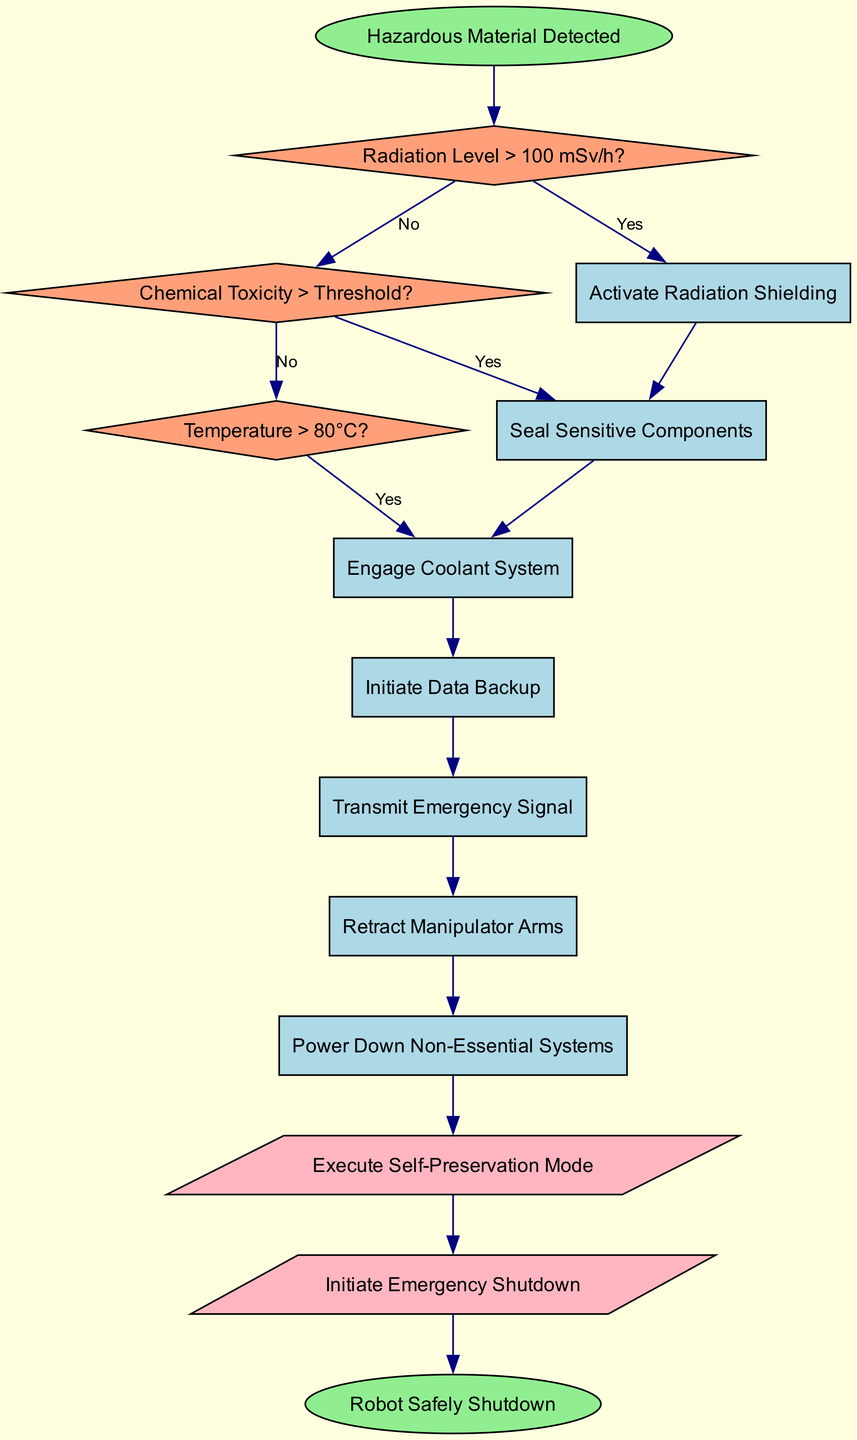What is the starting point of the flowchart? The flowchart begins with the node labeled "Hazardous Material Detected," which is defined as the starting point in the data provided.
Answer: Hazardous Material Detected How many decision nodes are in the diagram? By counting the items in the "decisions" array from the data, there are three decision nodes represented in the flowchart.
Answer: 3 What action follows after detecting a radiation level greater than 100 mSv/h? If the condition of "Radiation Level > 100 mSv/h?" is met (i.e., answered 'Yes'), the corresponding action is to "Activate Radiation Shielding" as indicated in the flowchart.
Answer: Activate Radiation Shielding What is the last action performed before the end node? The last action pointing to the final actions is "Power Down Non-Essential Systems," which leads to the final actions of self-preservation and emergency shutdown.
Answer: Power Down Non-Essential Systems If chemical toxicity exceeds the threshold, which action is taken after that? Upon identifying the condition "Chemical Toxicity > Threshold?" as true (Yes), the immediate corresponding action is to "Seal Sensitive Components."
Answer: Seal Sensitive Components What is the significance of the final actions in the flowchart? The final actions serve specific purposes for the robot, which are to execute a self-preservation mode and then to initiate an emergency shutdown process, thus ensuring the safety of the robot during hazardous conditions.
Answer: Execute Self-Preservation Mode and Initiate Emergency Shutdown Which action might be executed if the temperature exceeds 80°C? If the condition "Temperature > 80°C?" is satisfied, the corresponding action taken in response would be to "Engage Coolant System," which helps in managing the temperature.
Answer: Engage Coolant System What shape represents the decision nodes in the flowchart? The decision nodes in the flowchart are represented by diamonds, a standard shape for indicating decision points in flowcharts.
Answer: Diamond 